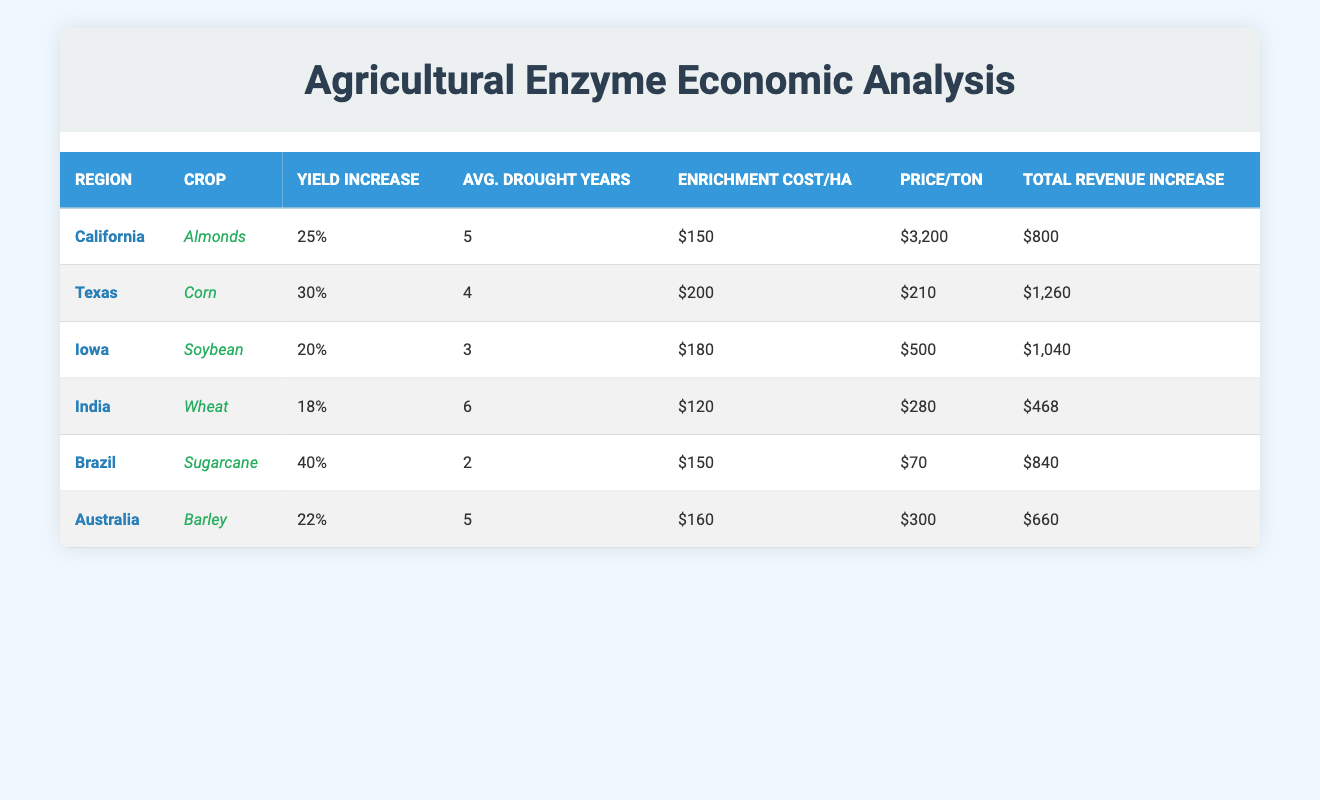What is the crop with the highest yield increase percentage? The table shows the yield increase percentages for various crops. By comparing the yield increase percentages, Sugarcane has the highest yield increase percentage of 40%.
Answer: Sugarcane Which region has the highest total revenue increase? By inspecting the total revenue increase column, Texas has the highest total revenue increase of 1260, compared to the other regions listed.
Answer: Texas What is the average enrichment cost per hectare for the listed crops? The enrichment costs are 150, 200, 180, 120, 150, and 160. Summing these values gives 1,060. Dividing by the number of regions (6) results in an average enrichment cost of 1,060 / 6 = approximately 176.67.
Answer: 176.67 Is the price per ton for Wheat greater than 250? The price per ton for Wheat is 280, which is indeed greater than 250, thereby answering the question with a true statement.
Answer: Yes How much greater is the total revenue increase for Corn compared to Wheat? The total revenue increase for Corn is 1,260 and for Wheat is 468. The difference is calculated as 1,260 - 468 = 792, indicating Corn has a total revenue increase that is 792 greater than that of Wheat.
Answer: 792 During which region's drought years is the yield increase percentage less than 20%? By examining the average drought years in conjunction with the yield increase percentages, both Iowa (with 20%) and India (with 18%) reflect yield increases less than 20% in their respective average drought years of 3 and 6.
Answer: Iowa and India What is the total revenue increase for Barley and Almonds combined? The total revenue increase for Barley is 660 and for Almonds is 800. Adding these two figures together gives 660 + 800 = 1460. Thus, the total revenue increase for both crops combined is 1460.
Answer: 1460 Which region has the lowest price per ton, and what is that price? By checking the price per ton column, Brazil has the lowest price per ton at 70.
Answer: Brazil, 70 How many regions have an average of more than 4 drought years? By looking at the average drought years for each region, California (5), Australia (5), and India (6) all report more than 4 drought years, totaling 3 regions.
Answer: 3 